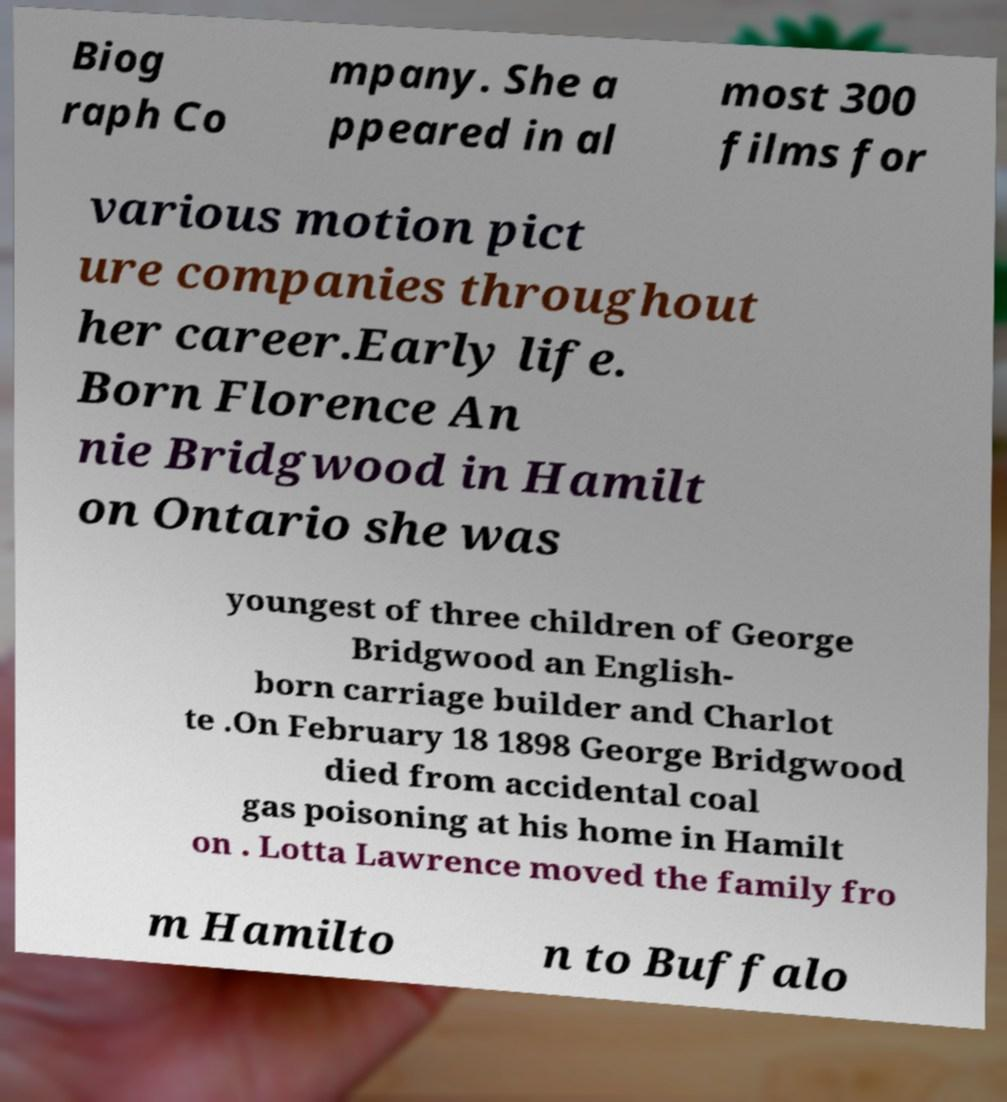Can you read and provide the text displayed in the image?This photo seems to have some interesting text. Can you extract and type it out for me? Biog raph Co mpany. She a ppeared in al most 300 films for various motion pict ure companies throughout her career.Early life. Born Florence An nie Bridgwood in Hamilt on Ontario she was youngest of three children of George Bridgwood an English- born carriage builder and Charlot te .On February 18 1898 George Bridgwood died from accidental coal gas poisoning at his home in Hamilt on . Lotta Lawrence moved the family fro m Hamilto n to Buffalo 